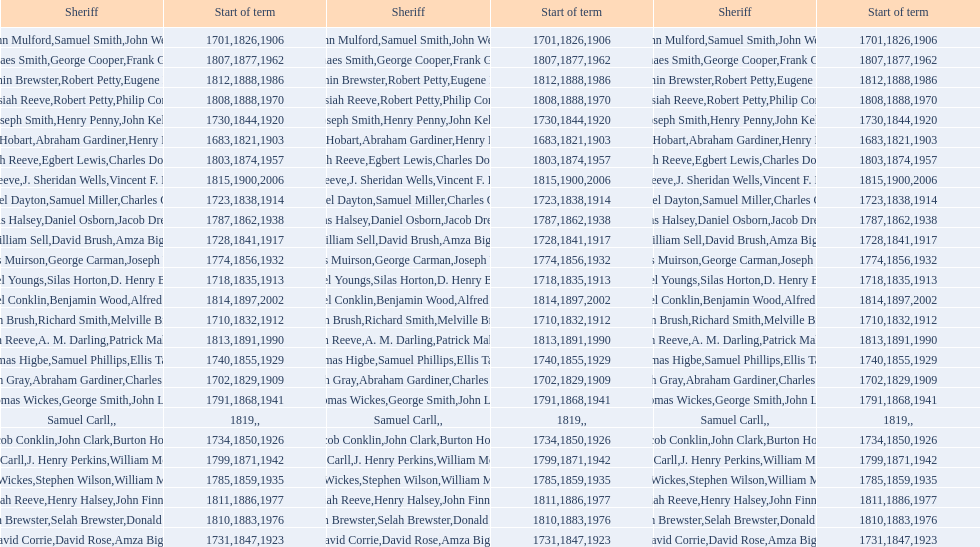Would you be able to parse every entry in this table? {'header': ['Sheriff', 'Start of term', 'Sheriff', 'Start of term', 'Sheriff', 'Start of term'], 'rows': [['John Mulford', '1701', 'Samuel Smith', '1826', 'John Wells', '1906'], ['Phinaes Smith', '1807', 'George Cooper', '1877', 'Frank Gross', '1962'], ['Benjamin Brewster', '1812', 'Robert Petty', '1888', 'Eugene Dooley', '1986'], ['Josiah Reeve', '1808', 'Robert Petty', '1888', 'Philip Corso', '1970'], ['Joseph Smith', '1730', 'Henry Penny', '1844', 'John Kelly', '1920'], ['Josiah Hobart', '1683', 'Abraham Gardiner', '1821', 'Henry Preston', '1903'], ['Josiah Reeve', '1803', 'Egbert Lewis', '1874', 'Charles Dominy', '1957'], ['Josiah Reeve', '1815', 'J. Sheridan Wells', '1900', 'Vincent F. DeMarco', '2006'], ['Samuel Dayton', '1723', 'Samuel Miller', '1838', "Charles O'Dell", '1914'], ['Silas Halsey', '1787', 'Daniel Osborn', '1862', 'Jacob Dreyer', '1938'], ['William Sell', '1728', 'David Brush', '1841', 'Amza Biggs', '1917'], ['James Muirson', '1774', 'George Carman', '1856', 'Joseph Warta', '1932'], ['Daniel Youngs', '1718', 'Silas Horton', '1835', 'D. Henry Brown', '1913'], ['Nathaniel Conklin', '1814', 'Benjamin Wood', '1897', 'Alfred C. Tisch', '2002'], ['John Brush', '1710', 'Richard Smith', '1832', 'Melville Brush', '1912'], ['Josiah Reeve', '1813', 'A. M. Darling', '1891', 'Patrick Mahoney', '1990'], ['Thomas Higbe', '1740', 'Samuel Phillips', '1855', 'Ellis Taylor', '1929'], ['Hugh Gray', '1702', 'Abraham Gardiner', '1829', 'Charles Platt', '1909'], ['Thomas Wickes', '1791', 'George Smith', '1868', 'John Levy', '1941'], ['Samuel Carll', '1819', '', '', '', ''], ['Jacob Conklin', '1734', 'John Clark', '1850', 'Burton Howe', '1926'], ['Phinaes Carll', '1799', 'J. Henry Perkins', '1871', 'William McCollom', '1942'], ['Thomas Wickes', '1785', 'Stephen Wilson', '1859', 'William McCollom', '1935'], ['Josiah Reeve', '1811', 'Henry Halsey', '1886', 'John Finnerty', '1977'], ['Benjamin Brewster', '1810', 'Selah Brewster', '1883', 'Donald Dilworth', '1976'], ['David Corrie', '1731', 'David Rose', '1847', 'Amza Biggs', '1923']]} What is the number of sheriff's with the last name smith? 5. 